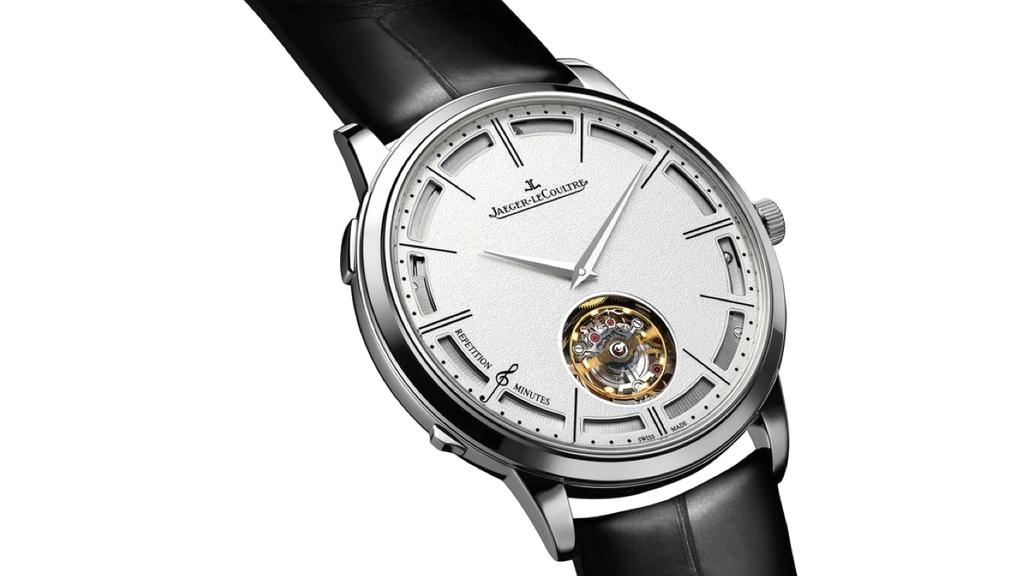What brand of watch is featured here?
Offer a very short reply. Jaeger-lecoultre. 